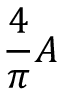Convert formula to latex. <formula><loc_0><loc_0><loc_500><loc_500>{ \frac { 4 } { \pi } } A \,</formula> 